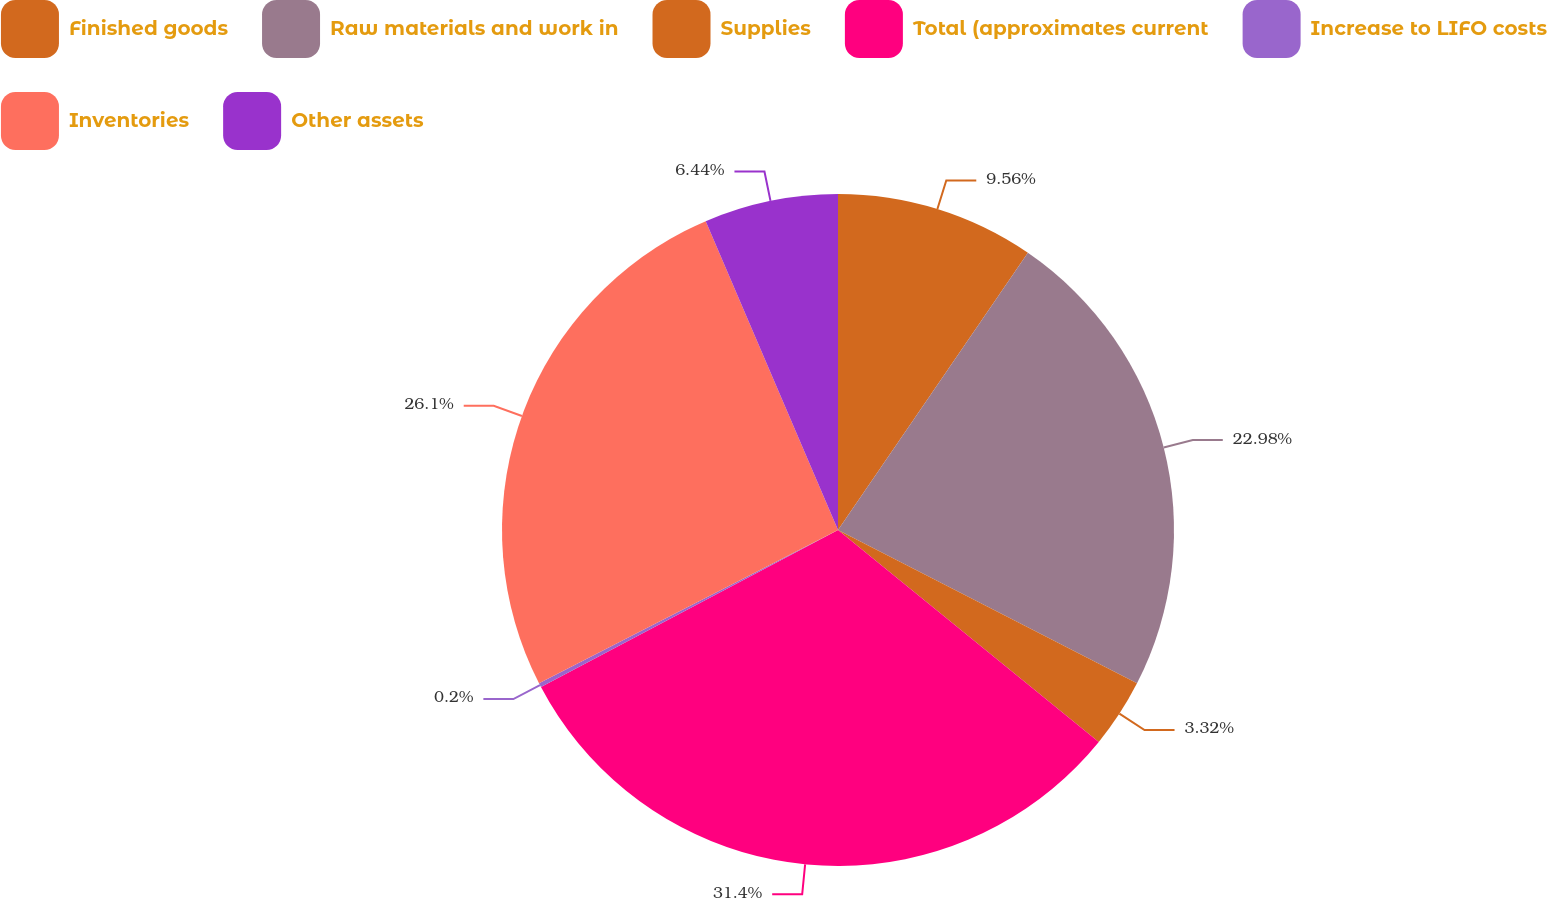<chart> <loc_0><loc_0><loc_500><loc_500><pie_chart><fcel>Finished goods<fcel>Raw materials and work in<fcel>Supplies<fcel>Total (approximates current<fcel>Increase to LIFO costs<fcel>Inventories<fcel>Other assets<nl><fcel>9.56%<fcel>22.98%<fcel>3.32%<fcel>31.4%<fcel>0.2%<fcel>26.1%<fcel>6.44%<nl></chart> 